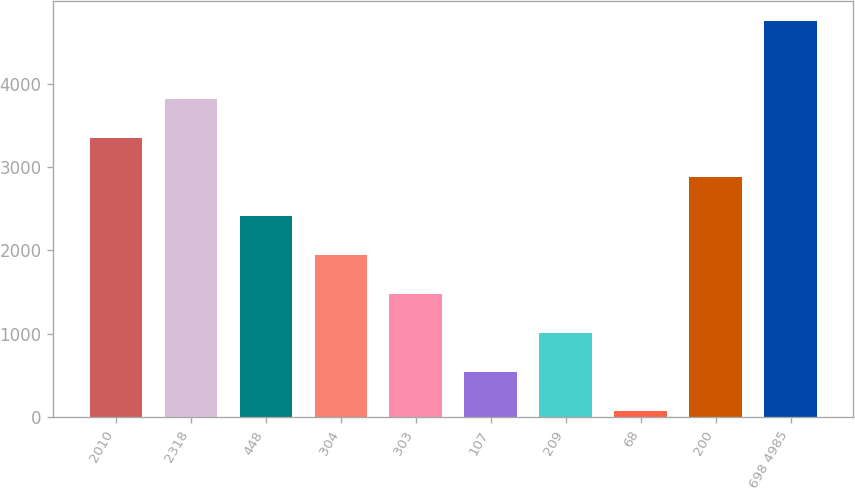Convert chart to OTSL. <chart><loc_0><loc_0><loc_500><loc_500><bar_chart><fcel>2010<fcel>2318<fcel>448<fcel>304<fcel>303<fcel>107<fcel>209<fcel>68<fcel>200<fcel>698 4985<nl><fcel>3348.2<fcel>3815.8<fcel>2413<fcel>1945.4<fcel>1477.8<fcel>542.6<fcel>1010.2<fcel>75<fcel>2880.6<fcel>4751<nl></chart> 